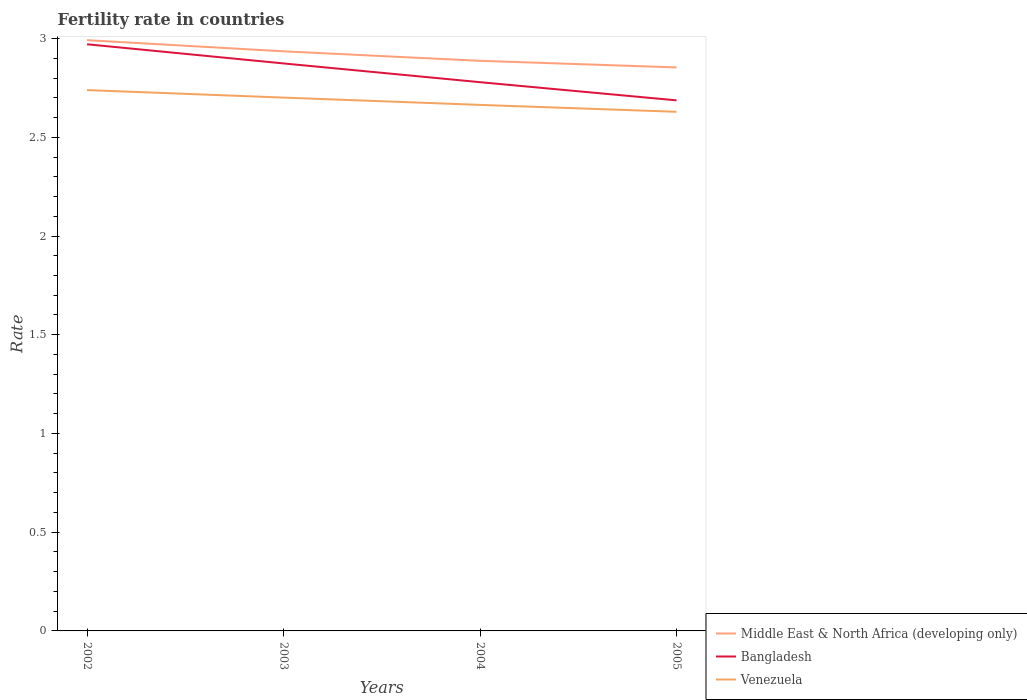How many different coloured lines are there?
Ensure brevity in your answer.  3. Does the line corresponding to Venezuela intersect with the line corresponding to Bangladesh?
Give a very brief answer. No. Across all years, what is the maximum fertility rate in Bangladesh?
Make the answer very short. 2.69. What is the total fertility rate in Venezuela in the graph?
Your answer should be very brief. 0.07. What is the difference between the highest and the second highest fertility rate in Middle East & North Africa (developing only)?
Give a very brief answer. 0.14. What is the difference between the highest and the lowest fertility rate in Venezuela?
Offer a terse response. 2. How many years are there in the graph?
Your response must be concise. 4. What is the difference between two consecutive major ticks on the Y-axis?
Your answer should be compact. 0.5. Are the values on the major ticks of Y-axis written in scientific E-notation?
Offer a terse response. No. Does the graph contain any zero values?
Ensure brevity in your answer.  No. Does the graph contain grids?
Make the answer very short. No. How are the legend labels stacked?
Provide a succinct answer. Vertical. What is the title of the graph?
Make the answer very short. Fertility rate in countries. What is the label or title of the X-axis?
Ensure brevity in your answer.  Years. What is the label or title of the Y-axis?
Offer a terse response. Rate. What is the Rate of Middle East & North Africa (developing only) in 2002?
Offer a very short reply. 2.99. What is the Rate in Bangladesh in 2002?
Keep it short and to the point. 2.97. What is the Rate in Venezuela in 2002?
Your answer should be compact. 2.74. What is the Rate of Middle East & North Africa (developing only) in 2003?
Your response must be concise. 2.94. What is the Rate of Bangladesh in 2003?
Your answer should be very brief. 2.87. What is the Rate of Venezuela in 2003?
Keep it short and to the point. 2.7. What is the Rate of Middle East & North Africa (developing only) in 2004?
Offer a terse response. 2.89. What is the Rate in Bangladesh in 2004?
Provide a short and direct response. 2.78. What is the Rate of Venezuela in 2004?
Give a very brief answer. 2.66. What is the Rate in Middle East & North Africa (developing only) in 2005?
Provide a short and direct response. 2.85. What is the Rate of Bangladesh in 2005?
Your answer should be very brief. 2.69. What is the Rate in Venezuela in 2005?
Give a very brief answer. 2.63. Across all years, what is the maximum Rate in Middle East & North Africa (developing only)?
Offer a very short reply. 2.99. Across all years, what is the maximum Rate in Bangladesh?
Offer a terse response. 2.97. Across all years, what is the maximum Rate in Venezuela?
Your answer should be compact. 2.74. Across all years, what is the minimum Rate of Middle East & North Africa (developing only)?
Provide a succinct answer. 2.85. Across all years, what is the minimum Rate of Bangladesh?
Ensure brevity in your answer.  2.69. Across all years, what is the minimum Rate in Venezuela?
Keep it short and to the point. 2.63. What is the total Rate in Middle East & North Africa (developing only) in the graph?
Your answer should be very brief. 11.67. What is the total Rate of Bangladesh in the graph?
Give a very brief answer. 11.31. What is the total Rate of Venezuela in the graph?
Your answer should be compact. 10.73. What is the difference between the Rate in Middle East & North Africa (developing only) in 2002 and that in 2003?
Provide a succinct answer. 0.06. What is the difference between the Rate in Bangladesh in 2002 and that in 2003?
Make the answer very short. 0.1. What is the difference between the Rate in Venezuela in 2002 and that in 2003?
Offer a terse response. 0.04. What is the difference between the Rate in Middle East & North Africa (developing only) in 2002 and that in 2004?
Provide a short and direct response. 0.1. What is the difference between the Rate in Bangladesh in 2002 and that in 2004?
Your answer should be compact. 0.19. What is the difference between the Rate in Venezuela in 2002 and that in 2004?
Offer a terse response. 0.07. What is the difference between the Rate in Middle East & North Africa (developing only) in 2002 and that in 2005?
Offer a terse response. 0.14. What is the difference between the Rate of Bangladesh in 2002 and that in 2005?
Your answer should be very brief. 0.28. What is the difference between the Rate in Venezuela in 2002 and that in 2005?
Give a very brief answer. 0.11. What is the difference between the Rate in Middle East & North Africa (developing only) in 2003 and that in 2004?
Provide a succinct answer. 0.05. What is the difference between the Rate in Bangladesh in 2003 and that in 2004?
Ensure brevity in your answer.  0.1. What is the difference between the Rate in Venezuela in 2003 and that in 2004?
Make the answer very short. 0.04. What is the difference between the Rate in Middle East & North Africa (developing only) in 2003 and that in 2005?
Your answer should be compact. 0.08. What is the difference between the Rate in Bangladesh in 2003 and that in 2005?
Offer a very short reply. 0.19. What is the difference between the Rate in Venezuela in 2003 and that in 2005?
Offer a terse response. 0.07. What is the difference between the Rate of Middle East & North Africa (developing only) in 2004 and that in 2005?
Provide a short and direct response. 0.03. What is the difference between the Rate of Bangladesh in 2004 and that in 2005?
Your answer should be compact. 0.09. What is the difference between the Rate of Venezuela in 2004 and that in 2005?
Make the answer very short. 0.04. What is the difference between the Rate of Middle East & North Africa (developing only) in 2002 and the Rate of Bangladesh in 2003?
Offer a very short reply. 0.12. What is the difference between the Rate in Middle East & North Africa (developing only) in 2002 and the Rate in Venezuela in 2003?
Give a very brief answer. 0.29. What is the difference between the Rate in Bangladesh in 2002 and the Rate in Venezuela in 2003?
Your response must be concise. 0.27. What is the difference between the Rate in Middle East & North Africa (developing only) in 2002 and the Rate in Bangladesh in 2004?
Make the answer very short. 0.21. What is the difference between the Rate in Middle East & North Africa (developing only) in 2002 and the Rate in Venezuela in 2004?
Keep it short and to the point. 0.33. What is the difference between the Rate in Bangladesh in 2002 and the Rate in Venezuela in 2004?
Offer a very short reply. 0.31. What is the difference between the Rate of Middle East & North Africa (developing only) in 2002 and the Rate of Bangladesh in 2005?
Your answer should be very brief. 0.3. What is the difference between the Rate of Middle East & North Africa (developing only) in 2002 and the Rate of Venezuela in 2005?
Give a very brief answer. 0.36. What is the difference between the Rate in Bangladesh in 2002 and the Rate in Venezuela in 2005?
Ensure brevity in your answer.  0.34. What is the difference between the Rate in Middle East & North Africa (developing only) in 2003 and the Rate in Bangladesh in 2004?
Ensure brevity in your answer.  0.16. What is the difference between the Rate in Middle East & North Africa (developing only) in 2003 and the Rate in Venezuela in 2004?
Offer a terse response. 0.27. What is the difference between the Rate in Bangladesh in 2003 and the Rate in Venezuela in 2004?
Offer a very short reply. 0.21. What is the difference between the Rate in Middle East & North Africa (developing only) in 2003 and the Rate in Bangladesh in 2005?
Offer a terse response. 0.25. What is the difference between the Rate in Middle East & North Africa (developing only) in 2003 and the Rate in Venezuela in 2005?
Keep it short and to the point. 0.31. What is the difference between the Rate in Bangladesh in 2003 and the Rate in Venezuela in 2005?
Keep it short and to the point. 0.24. What is the difference between the Rate in Middle East & North Africa (developing only) in 2004 and the Rate in Bangladesh in 2005?
Make the answer very short. 0.2. What is the difference between the Rate in Middle East & North Africa (developing only) in 2004 and the Rate in Venezuela in 2005?
Keep it short and to the point. 0.26. What is the difference between the Rate of Bangladesh in 2004 and the Rate of Venezuela in 2005?
Your answer should be very brief. 0.15. What is the average Rate of Middle East & North Africa (developing only) per year?
Offer a terse response. 2.92. What is the average Rate of Bangladesh per year?
Offer a terse response. 2.83. What is the average Rate in Venezuela per year?
Your answer should be very brief. 2.68. In the year 2002, what is the difference between the Rate in Middle East & North Africa (developing only) and Rate in Bangladesh?
Your answer should be very brief. 0.02. In the year 2002, what is the difference between the Rate of Middle East & North Africa (developing only) and Rate of Venezuela?
Offer a terse response. 0.25. In the year 2002, what is the difference between the Rate in Bangladesh and Rate in Venezuela?
Your answer should be very brief. 0.23. In the year 2003, what is the difference between the Rate of Middle East & North Africa (developing only) and Rate of Bangladesh?
Keep it short and to the point. 0.06. In the year 2003, what is the difference between the Rate in Middle East & North Africa (developing only) and Rate in Venezuela?
Give a very brief answer. 0.23. In the year 2003, what is the difference between the Rate of Bangladesh and Rate of Venezuela?
Offer a very short reply. 0.17. In the year 2004, what is the difference between the Rate of Middle East & North Africa (developing only) and Rate of Bangladesh?
Your answer should be very brief. 0.11. In the year 2004, what is the difference between the Rate of Middle East & North Africa (developing only) and Rate of Venezuela?
Your answer should be very brief. 0.22. In the year 2004, what is the difference between the Rate of Bangladesh and Rate of Venezuela?
Ensure brevity in your answer.  0.12. In the year 2005, what is the difference between the Rate in Middle East & North Africa (developing only) and Rate in Bangladesh?
Offer a very short reply. 0.17. In the year 2005, what is the difference between the Rate of Middle East & North Africa (developing only) and Rate of Venezuela?
Provide a short and direct response. 0.22. In the year 2005, what is the difference between the Rate of Bangladesh and Rate of Venezuela?
Ensure brevity in your answer.  0.06. What is the ratio of the Rate in Middle East & North Africa (developing only) in 2002 to that in 2003?
Provide a succinct answer. 1.02. What is the ratio of the Rate of Bangladesh in 2002 to that in 2003?
Your answer should be compact. 1.03. What is the ratio of the Rate in Venezuela in 2002 to that in 2003?
Make the answer very short. 1.01. What is the ratio of the Rate of Middle East & North Africa (developing only) in 2002 to that in 2004?
Offer a very short reply. 1.04. What is the ratio of the Rate of Bangladesh in 2002 to that in 2004?
Your response must be concise. 1.07. What is the ratio of the Rate of Venezuela in 2002 to that in 2004?
Your response must be concise. 1.03. What is the ratio of the Rate in Middle East & North Africa (developing only) in 2002 to that in 2005?
Offer a terse response. 1.05. What is the ratio of the Rate in Bangladesh in 2002 to that in 2005?
Your response must be concise. 1.11. What is the ratio of the Rate in Venezuela in 2002 to that in 2005?
Provide a short and direct response. 1.04. What is the ratio of the Rate of Middle East & North Africa (developing only) in 2003 to that in 2004?
Keep it short and to the point. 1.02. What is the ratio of the Rate in Bangladesh in 2003 to that in 2004?
Keep it short and to the point. 1.03. What is the ratio of the Rate of Venezuela in 2003 to that in 2004?
Your answer should be very brief. 1.01. What is the ratio of the Rate of Middle East & North Africa (developing only) in 2003 to that in 2005?
Ensure brevity in your answer.  1.03. What is the ratio of the Rate of Bangladesh in 2003 to that in 2005?
Offer a terse response. 1.07. What is the ratio of the Rate in Venezuela in 2003 to that in 2005?
Provide a short and direct response. 1.03. What is the ratio of the Rate in Middle East & North Africa (developing only) in 2004 to that in 2005?
Give a very brief answer. 1.01. What is the ratio of the Rate of Bangladesh in 2004 to that in 2005?
Make the answer very short. 1.03. What is the ratio of the Rate of Venezuela in 2004 to that in 2005?
Your answer should be compact. 1.01. What is the difference between the highest and the second highest Rate in Middle East & North Africa (developing only)?
Ensure brevity in your answer.  0.06. What is the difference between the highest and the second highest Rate in Bangladesh?
Provide a short and direct response. 0.1. What is the difference between the highest and the second highest Rate in Venezuela?
Your answer should be compact. 0.04. What is the difference between the highest and the lowest Rate of Middle East & North Africa (developing only)?
Your response must be concise. 0.14. What is the difference between the highest and the lowest Rate in Bangladesh?
Your answer should be compact. 0.28. What is the difference between the highest and the lowest Rate of Venezuela?
Give a very brief answer. 0.11. 